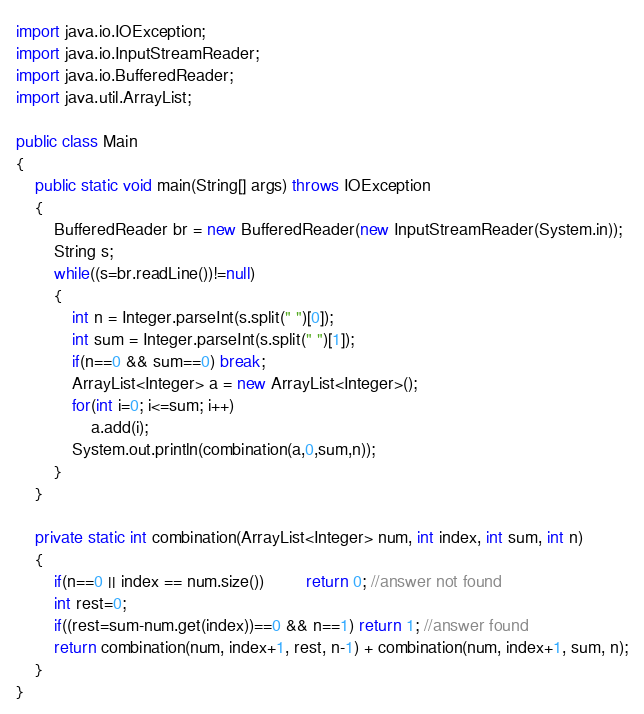Convert code to text. <code><loc_0><loc_0><loc_500><loc_500><_Java_>import java.io.IOException;
import java.io.InputStreamReader;
import java.io.BufferedReader;
import java.util.ArrayList;

public class Main
{
	public static void main(String[] args) throws IOException
	{
		BufferedReader br = new BufferedReader(new InputStreamReader(System.in));
		String s;
		while((s=br.readLine())!=null)
		{
			int n = Integer.parseInt(s.split(" ")[0]);
			int sum = Integer.parseInt(s.split(" ")[1]);
			if(n==0 && sum==0) break;
			ArrayList<Integer> a = new ArrayList<Integer>();
			for(int i=0; i<=sum; i++)
				a.add(i);
			System.out.println(combination(a,0,sum,n));
		}
	}

	private static int combination(ArrayList<Integer> num, int index, int sum, int n)
	{
		if(n==0 || index == num.size()) 		 return 0; //answer not found 
		int rest=0;
		if((rest=sum-num.get(index))==0 && n==1) return 1; //answer found
		return combination(num, index+1, rest, n-1) + combination(num, index+1, sum, n);
	}	
}</code> 